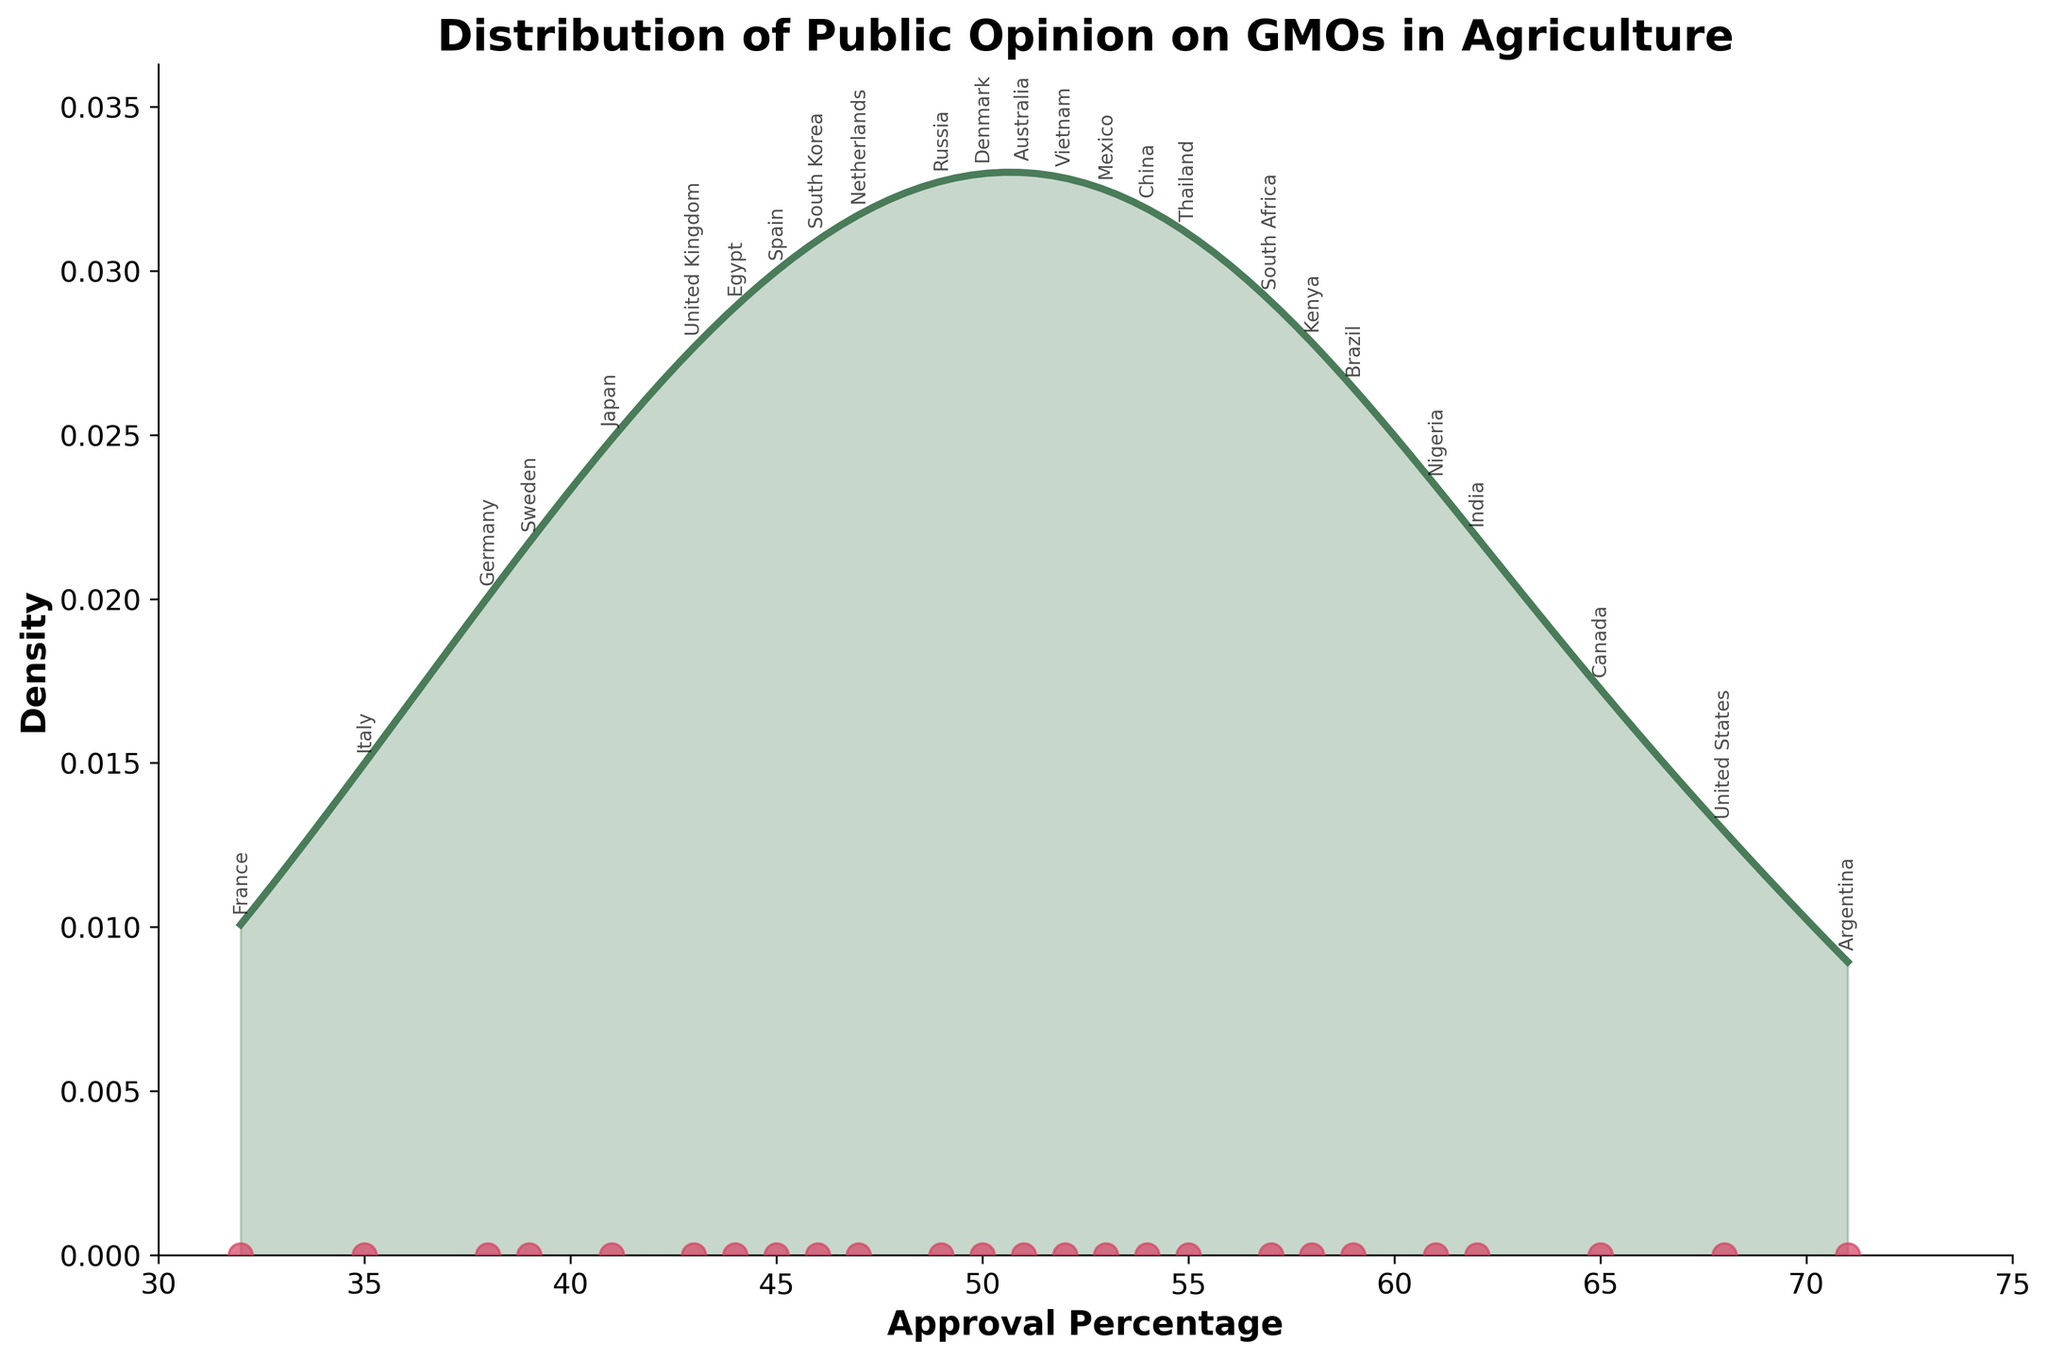What is the title of the figure? The title of the figure is generally located at the top of the plot. It provides a summary of what the plot is about. In this case, the title clearly states the main focus of the plot.
Answer: Distribution of Public Opinion on GMOs in Agriculture What is the approximate range of approval percentages? The x-axis represents the approval percentages ranging from the lowest to the highest values observed. By looking along the x-axis, you can ascertain this range.
Answer: 30 to 75 Which country has the highest approval percentage for GMOs in agriculture? The plot includes annotations for each country at their respective approval percentages. Identifying the highest point on the x-axis with a country label will indicate the highest approval percentage.
Answer: Argentina How does the approval percentage of the United Kingdom compare to that of Sweden? You can find both countries' approval percentages annotated on the plot. By checking their positions on the x-axis, you can compare which is higher.
Answer: The United Kingdom has a higher percentage (43%) than Sweden (39%) What does the y-axis represent in this plot? The y-axis on a density plot usually represents the density or frequency of the data points within the approval percentage range, showing how often certain percentages occur.
Answer: Density Which country appears closest to the average approval percentage of the displayed countries? To determine the average, you sum all the approval percentages and divide by the number of countries. Next, identify the country whose approval is nearest to this computed average.
Answer: The average approval percentage is around 51.1. Denmark (50%) is closest What is the median approval percentage, and which country's percentage is closest to it? The median is the middle value when all percentages are ordered. With 24 data points, it's the average of the 12th and 13th values. The density plot annotations help in identifying this value.
Answer: The median is 50.65. Denmark (50%) is closest Are there more countries with approval percentages above or below 50%? By looking at the x-axis and the number of country annotations on either side of 50%, we can compare the counts.
Answer: More countries have percentages above 50% Which countries fall within the highest density region of the plot? The highest density region on a density plot is where the curve peaks. Identify which countries' percentages lie within this peak region.
Answer: United States, Canada, Brazil, Argentina, and India What does the scatter at the bottom of the plot represent? The scatter plot places points directly on the x-axis to represent each country's approval percentage, enhancing the visibility of individual data points.
Answer: Individual country approval percentages 